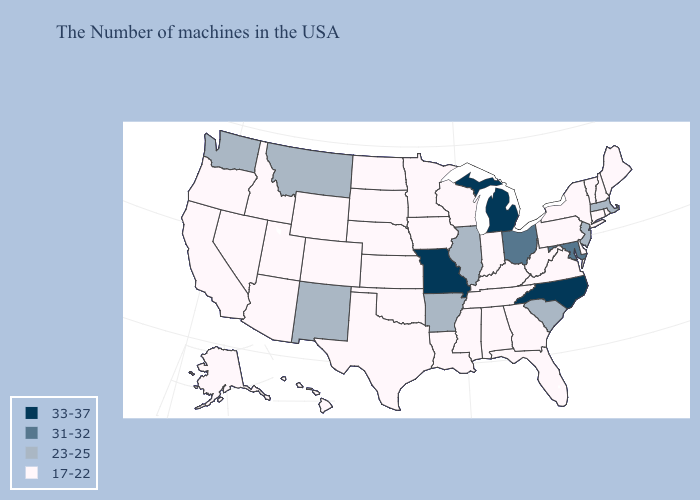Name the states that have a value in the range 17-22?
Give a very brief answer. Maine, Rhode Island, New Hampshire, Vermont, Connecticut, New York, Delaware, Pennsylvania, Virginia, West Virginia, Florida, Georgia, Kentucky, Indiana, Alabama, Tennessee, Wisconsin, Mississippi, Louisiana, Minnesota, Iowa, Kansas, Nebraska, Oklahoma, Texas, South Dakota, North Dakota, Wyoming, Colorado, Utah, Arizona, Idaho, Nevada, California, Oregon, Alaska, Hawaii. Name the states that have a value in the range 31-32?
Short answer required. Maryland, Ohio. What is the lowest value in the Northeast?
Give a very brief answer. 17-22. How many symbols are there in the legend?
Be succinct. 4. Is the legend a continuous bar?
Write a very short answer. No. What is the value of New Jersey?
Be succinct. 23-25. Which states have the highest value in the USA?
Answer briefly. North Carolina, Michigan, Missouri. What is the lowest value in states that border Nebraska?
Short answer required. 17-22. Name the states that have a value in the range 17-22?
Concise answer only. Maine, Rhode Island, New Hampshire, Vermont, Connecticut, New York, Delaware, Pennsylvania, Virginia, West Virginia, Florida, Georgia, Kentucky, Indiana, Alabama, Tennessee, Wisconsin, Mississippi, Louisiana, Minnesota, Iowa, Kansas, Nebraska, Oklahoma, Texas, South Dakota, North Dakota, Wyoming, Colorado, Utah, Arizona, Idaho, Nevada, California, Oregon, Alaska, Hawaii. Among the states that border Indiana , which have the highest value?
Quick response, please. Michigan. Which states have the lowest value in the USA?
Concise answer only. Maine, Rhode Island, New Hampshire, Vermont, Connecticut, New York, Delaware, Pennsylvania, Virginia, West Virginia, Florida, Georgia, Kentucky, Indiana, Alabama, Tennessee, Wisconsin, Mississippi, Louisiana, Minnesota, Iowa, Kansas, Nebraska, Oklahoma, Texas, South Dakota, North Dakota, Wyoming, Colorado, Utah, Arizona, Idaho, Nevada, California, Oregon, Alaska, Hawaii. Among the states that border Illinois , which have the highest value?
Write a very short answer. Missouri. Name the states that have a value in the range 31-32?
Give a very brief answer. Maryland, Ohio. Name the states that have a value in the range 17-22?
Give a very brief answer. Maine, Rhode Island, New Hampshire, Vermont, Connecticut, New York, Delaware, Pennsylvania, Virginia, West Virginia, Florida, Georgia, Kentucky, Indiana, Alabama, Tennessee, Wisconsin, Mississippi, Louisiana, Minnesota, Iowa, Kansas, Nebraska, Oklahoma, Texas, South Dakota, North Dakota, Wyoming, Colorado, Utah, Arizona, Idaho, Nevada, California, Oregon, Alaska, Hawaii. What is the lowest value in the MidWest?
Answer briefly. 17-22. 